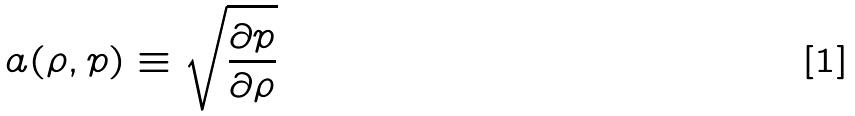Convert formula to latex. <formula><loc_0><loc_0><loc_500><loc_500>a ( \rho , p ) \equiv \sqrt { \frac { \partial p } { \partial \rho } }</formula> 